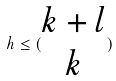<formula> <loc_0><loc_0><loc_500><loc_500>h \leq ( \begin{matrix} k + l \\ k \end{matrix} )</formula> 